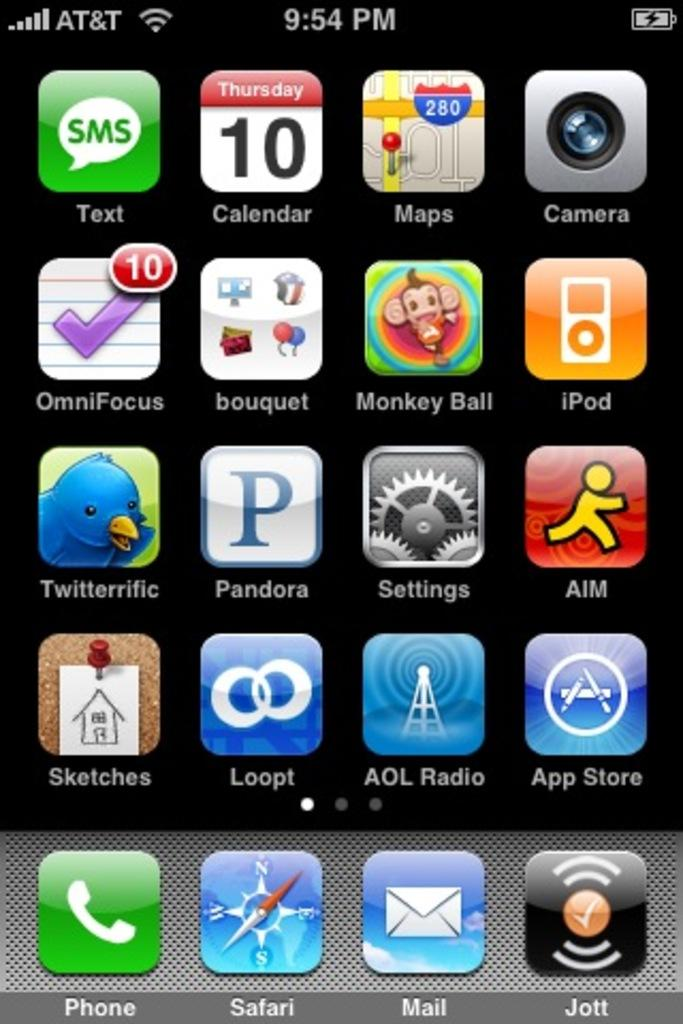Provide a one-sentence caption for the provided image. A phone screen with a Monkey Ball app on it. 